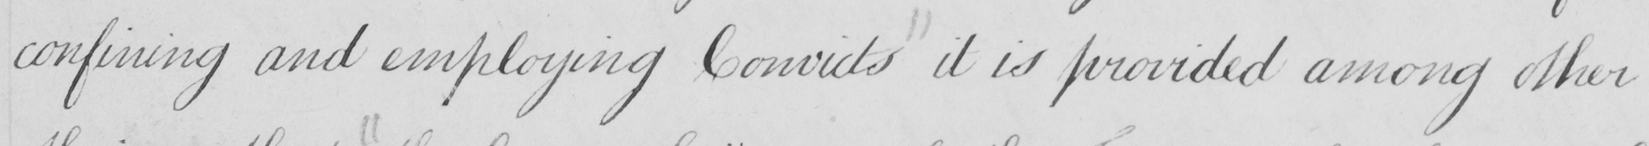Can you tell me what this handwritten text says? confining and employing Convicts it is provided among other 